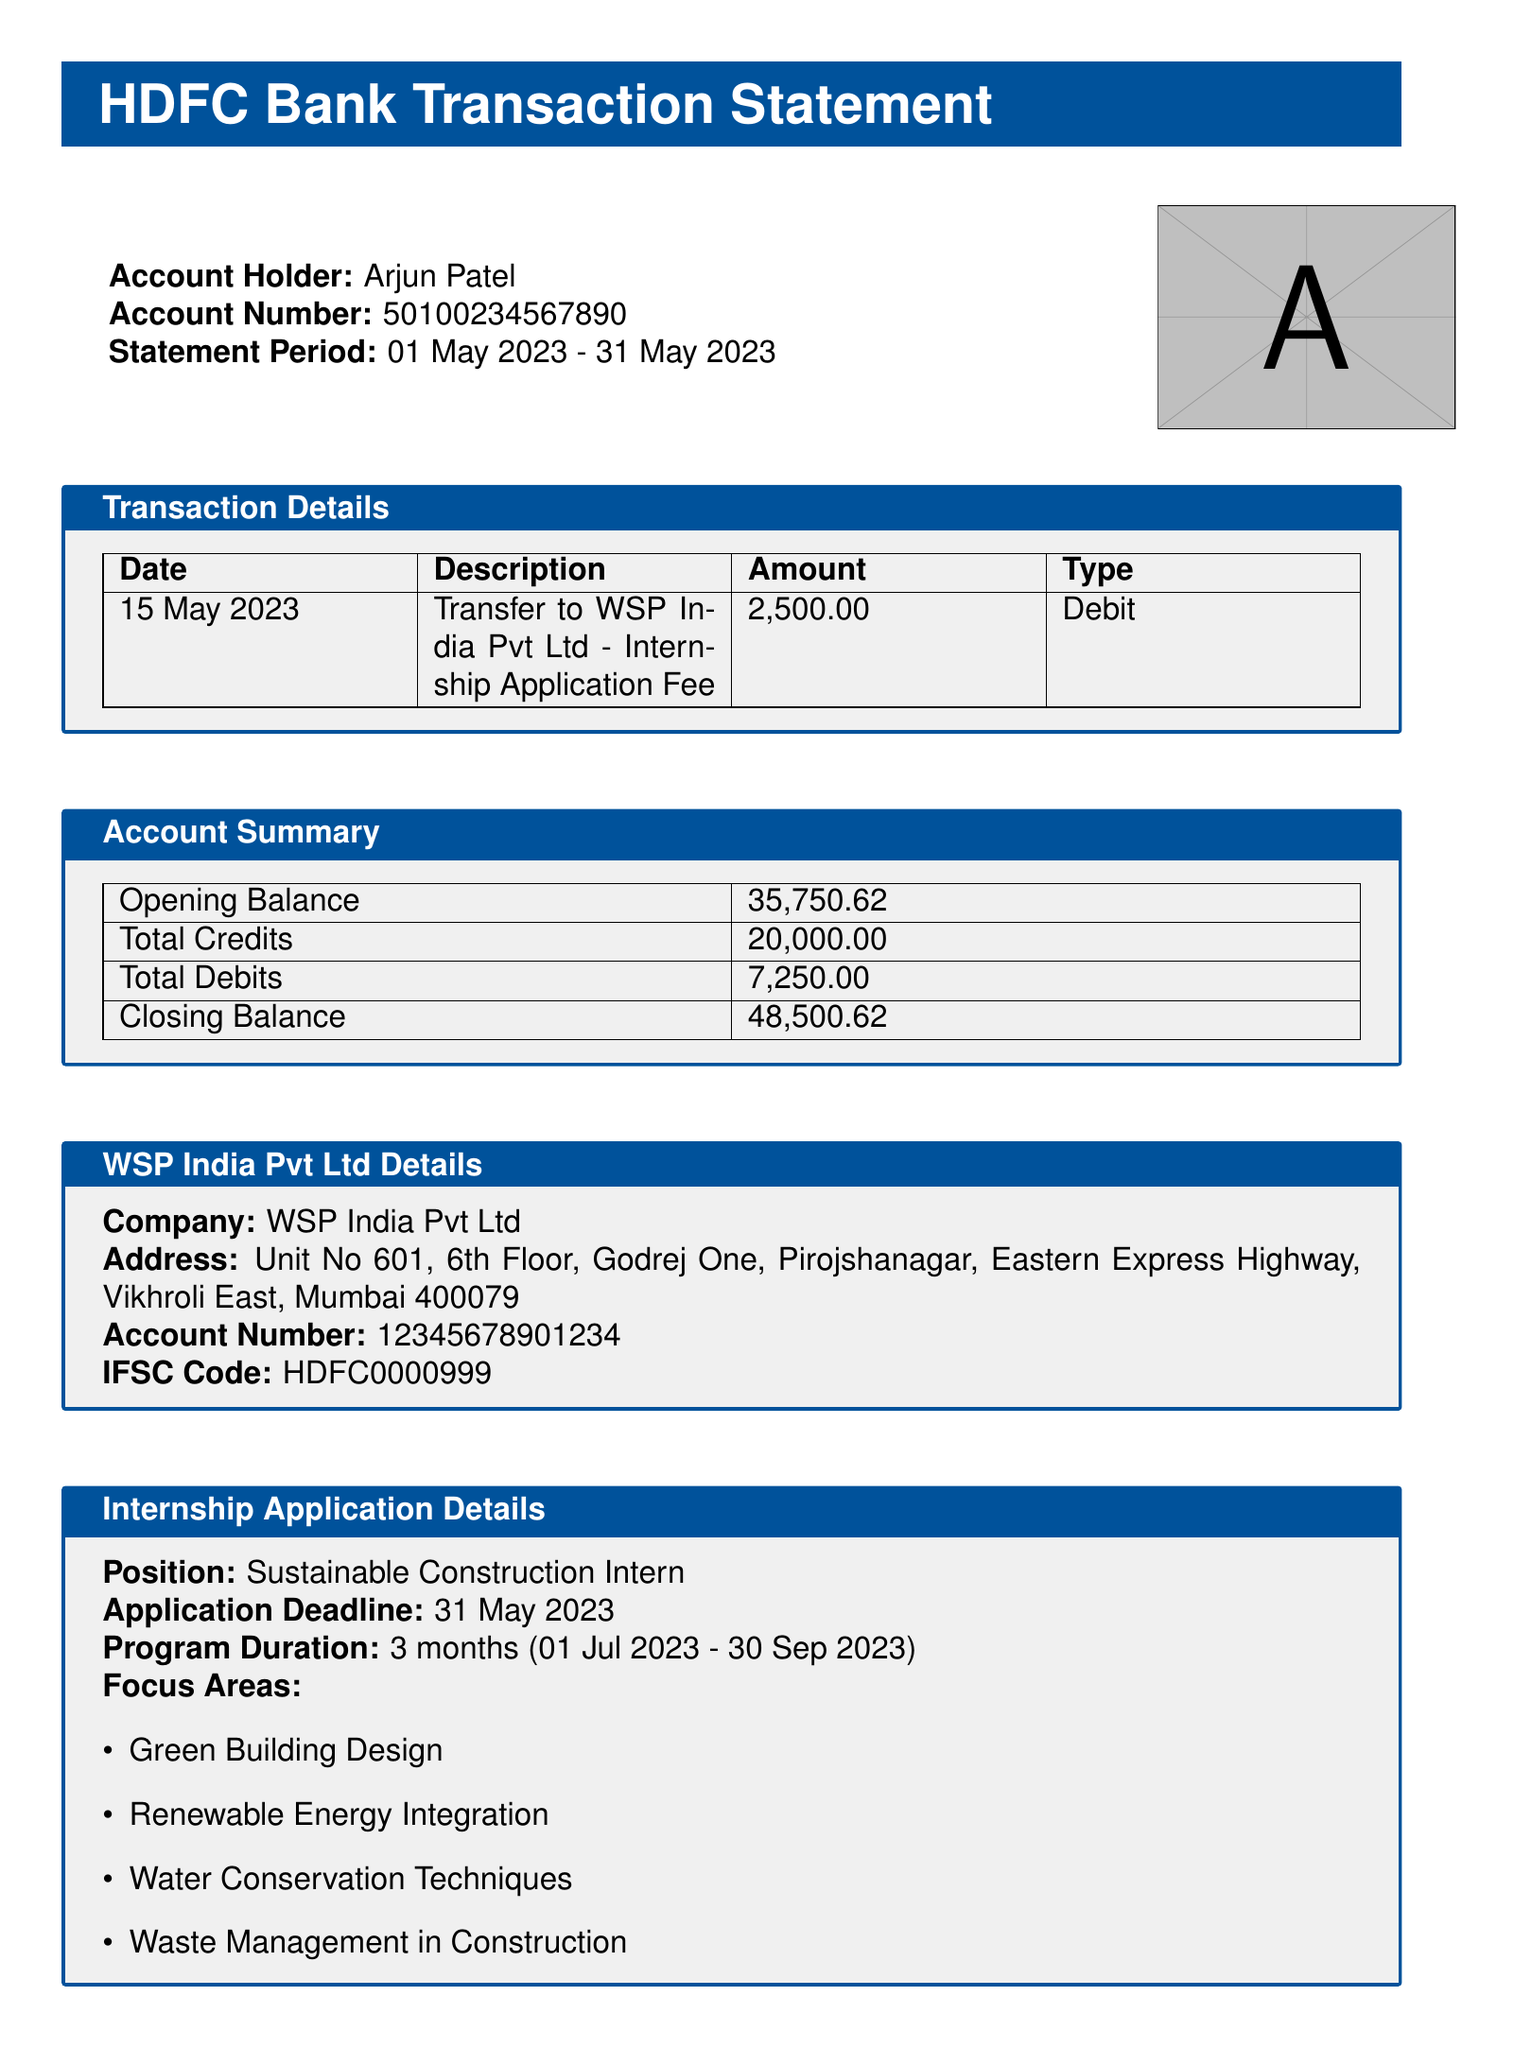what is the name of the account holder? The account holder's name is mentioned clearly in the document.
Answer: Arjun Patel what is the amount of the internship application fee? The transaction details include the specific amount that was transferred for the internship application fee.
Answer: ₹2,500.00 what is the closing balance of the account? The account summary provides the closing balance at the end of the statement period.
Answer: ₹48,500.62 when was the transaction made? The transaction details specify the date of the fund transfer.
Answer: 15 May 2023 what is the position for which the application fee was paid? The internship application details include the title of the position for which Arjun Patel applied.
Answer: Sustainable Construction Intern what university does the applicant attend? The applicant details section includes information about the university Arjun Patel is associated with.
Answer: Indian Institute of Technology Bombay how many total debits were recorded in the account summary? The account summary specifies the total amount of debits recorded during the statement period.
Answer: ₹7,250.00 what is the application deadline? The internship application details mention the deadline for submitting applications.
Answer: 31 May 2023 where is WSP India Pvt Ltd's office located? The document contains the complete address of WSP India Pvt Ltd.
Answer: Unit No 601, 6th Floor, Godrej One, Pirojshanagar, Eastern Express Highway, Vikhroli East, Mumbai 400079 